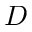Convert formula to latex. <formula><loc_0><loc_0><loc_500><loc_500>D</formula> 